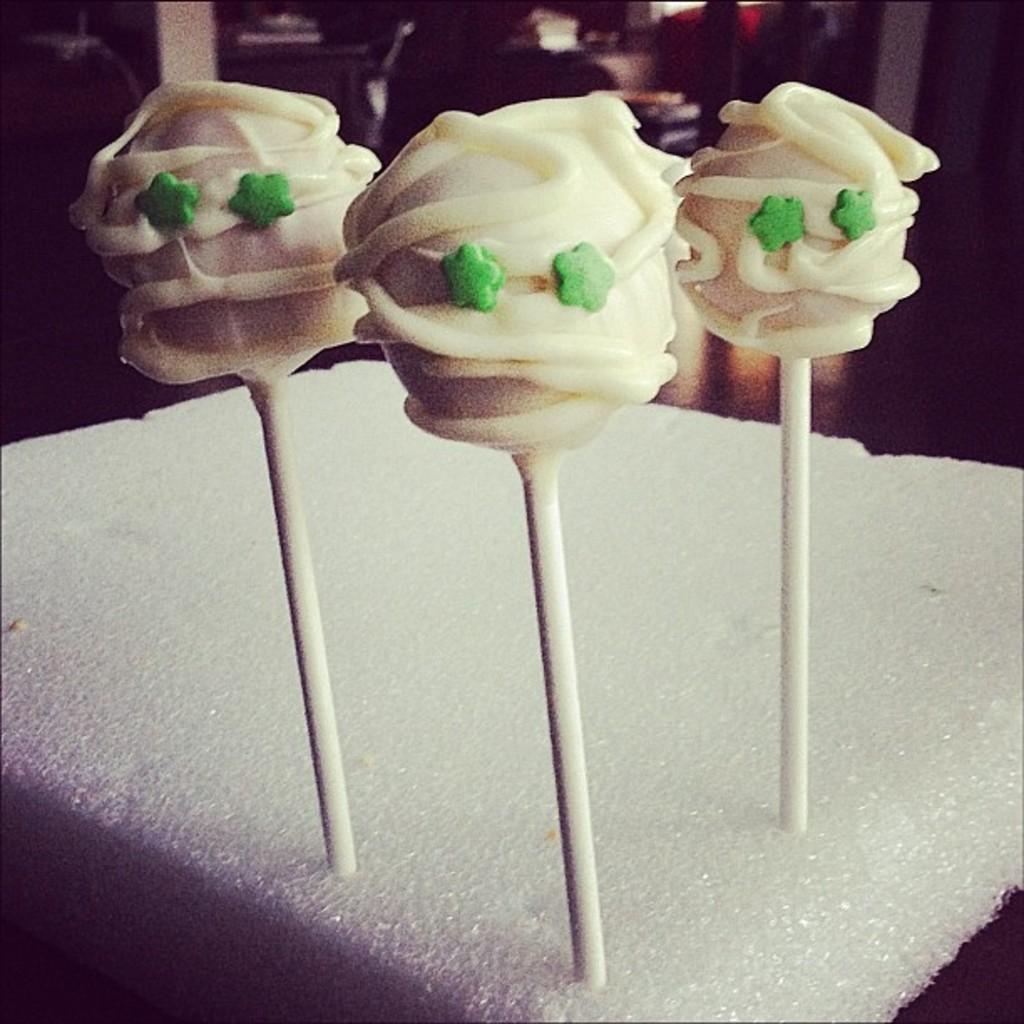Please provide a concise description of this image. In this image at front there are three sugar candies on the white surface. 